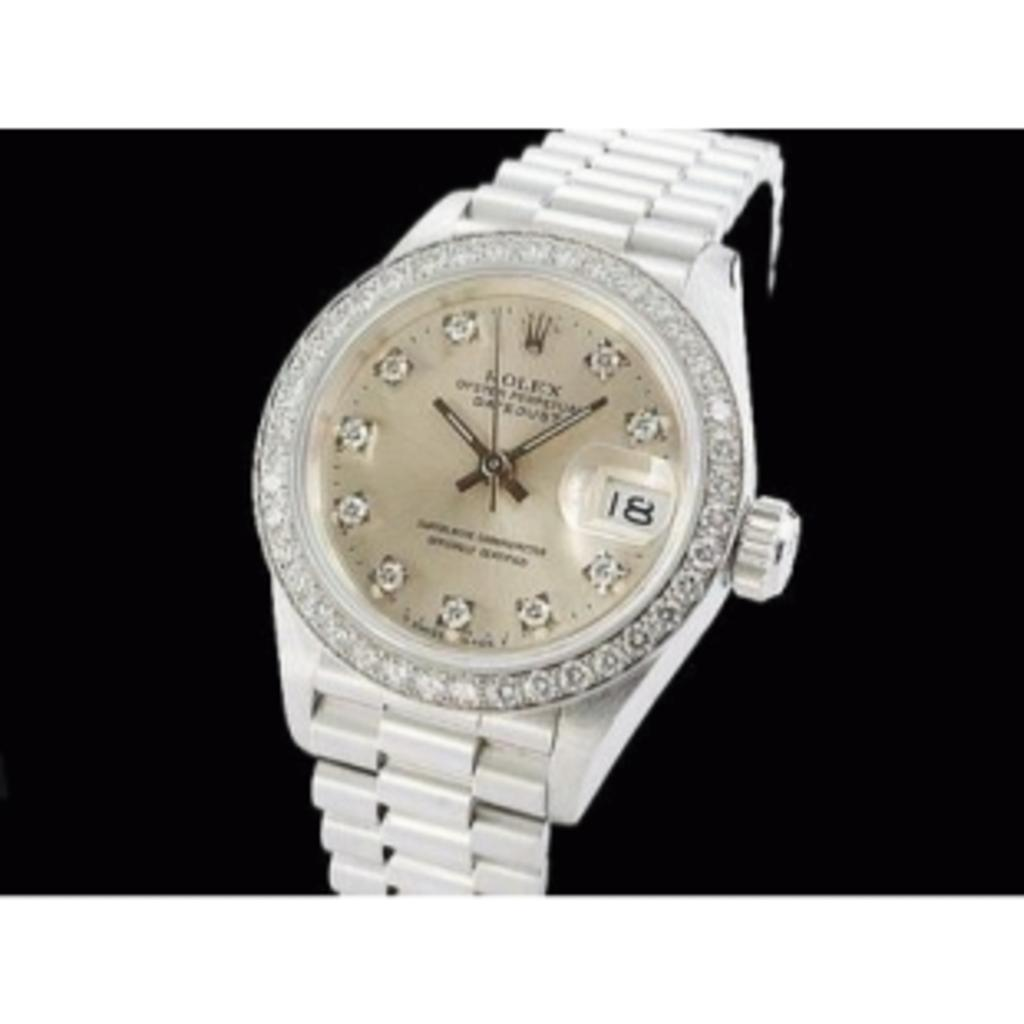<image>
Relay a brief, clear account of the picture shown. White wrist watch with the name ROLEx on the face. 